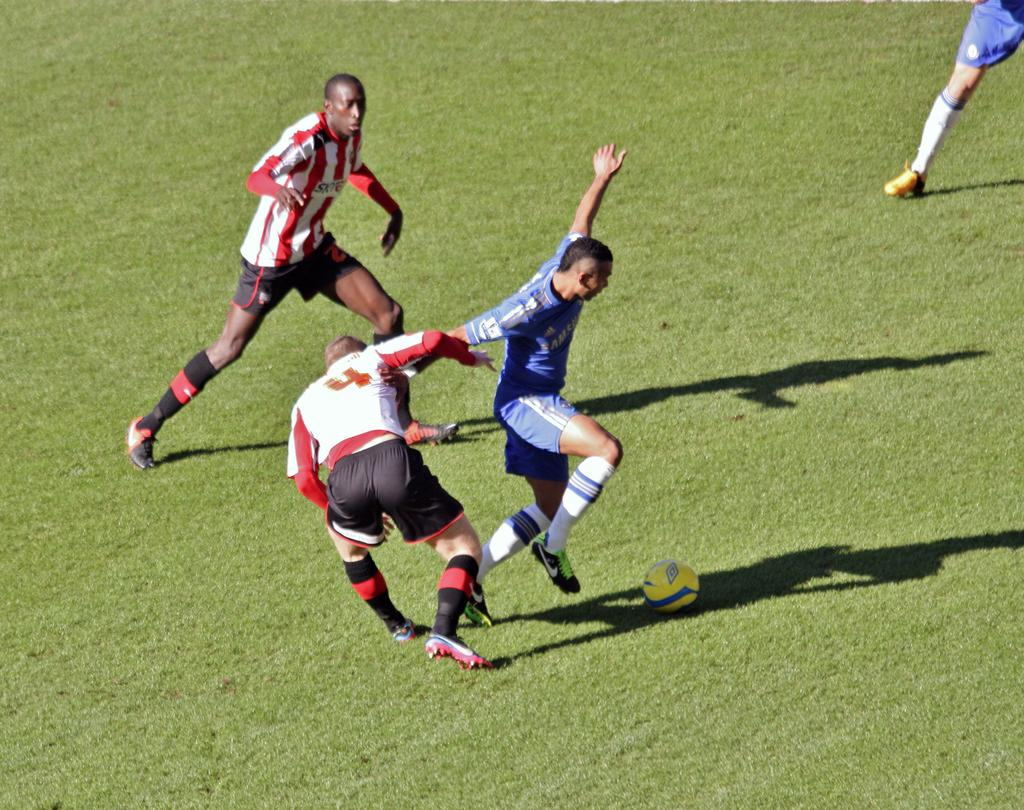What sport are the players engaged in within the image? The players are playing football. Where is the football game taking place? The football game is taking place on a ground. What can be observed about the players' shadows in the image? The shadows of the players are visible on the ground. What is the reason for the visibility of the shadows in the image? The visibility of the shadows is due to sunlight. What type of development is taking place in the image? There is no development project visible in the image; it features a football game. What is the players' lunch preference during the game? There is no information about the players' lunch preferences in the image. 